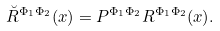<formula> <loc_0><loc_0><loc_500><loc_500>\breve { R } ^ { \Phi _ { 1 } \Phi _ { 2 } } ( x ) = P ^ { \Phi _ { 1 } \Phi _ { 2 } } R ^ { \Phi _ { 1 } \Phi _ { 2 } } ( x ) .</formula> 